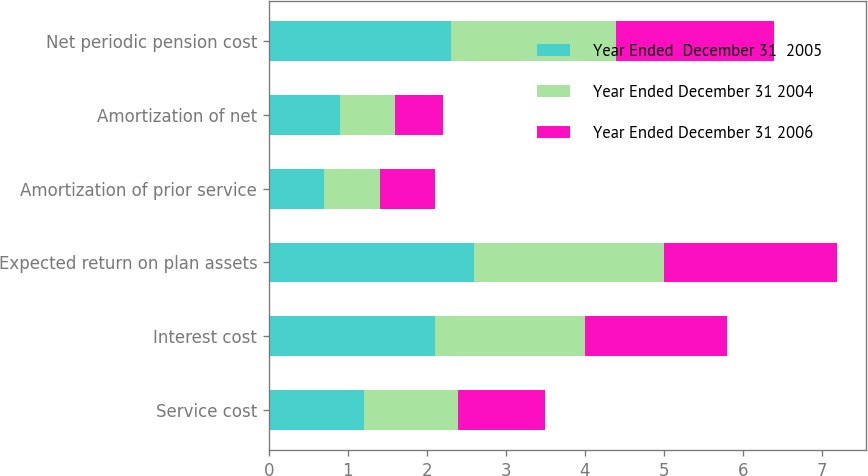Convert chart. <chart><loc_0><loc_0><loc_500><loc_500><stacked_bar_chart><ecel><fcel>Service cost<fcel>Interest cost<fcel>Expected return on plan assets<fcel>Amortization of prior service<fcel>Amortization of net<fcel>Net periodic pension cost<nl><fcel>Year Ended  December 31  2005<fcel>1.2<fcel>2.1<fcel>2.6<fcel>0.7<fcel>0.9<fcel>2.3<nl><fcel>Year Ended December 31 2004<fcel>1.2<fcel>1.9<fcel>2.4<fcel>0.7<fcel>0.7<fcel>2.1<nl><fcel>Year Ended December 31 2006<fcel>1.1<fcel>1.8<fcel>2.2<fcel>0.7<fcel>0.6<fcel>2<nl></chart> 